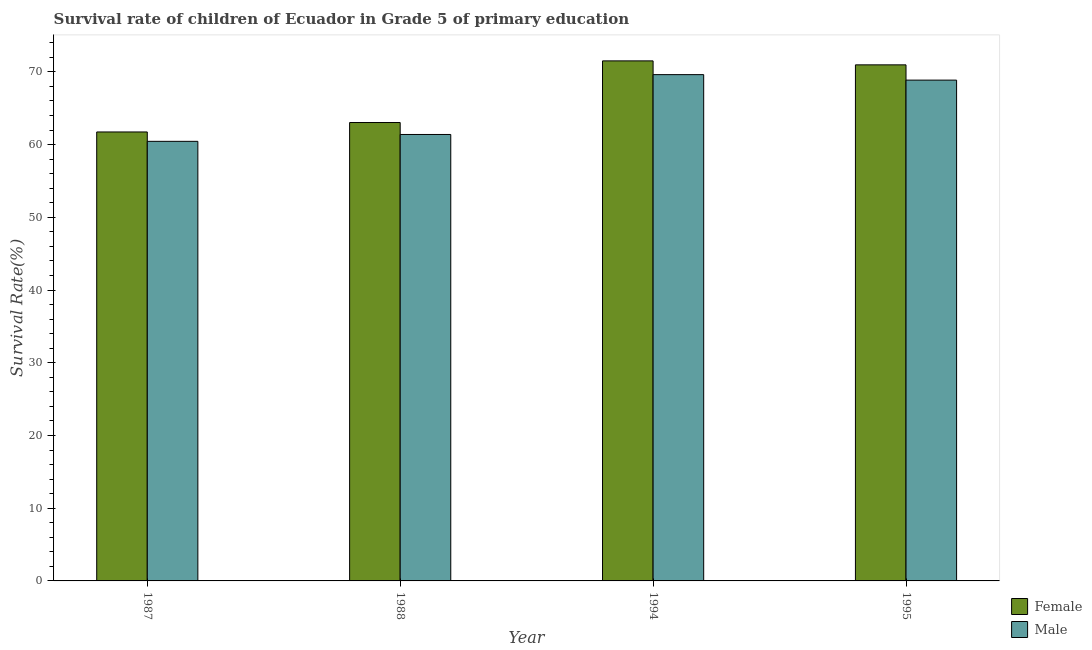How many different coloured bars are there?
Your response must be concise. 2. How many groups of bars are there?
Provide a succinct answer. 4. What is the label of the 1st group of bars from the left?
Your answer should be compact. 1987. In how many cases, is the number of bars for a given year not equal to the number of legend labels?
Your response must be concise. 0. What is the survival rate of male students in primary education in 1987?
Provide a short and direct response. 60.45. Across all years, what is the maximum survival rate of male students in primary education?
Offer a terse response. 69.62. Across all years, what is the minimum survival rate of male students in primary education?
Your response must be concise. 60.45. In which year was the survival rate of male students in primary education maximum?
Your answer should be very brief. 1994. What is the total survival rate of male students in primary education in the graph?
Offer a terse response. 260.34. What is the difference between the survival rate of male students in primary education in 1988 and that in 1994?
Your answer should be very brief. -8.23. What is the difference between the survival rate of male students in primary education in 1988 and the survival rate of female students in primary education in 1987?
Provide a short and direct response. 0.94. What is the average survival rate of male students in primary education per year?
Offer a terse response. 65.09. In the year 1995, what is the difference between the survival rate of male students in primary education and survival rate of female students in primary education?
Offer a very short reply. 0. In how many years, is the survival rate of female students in primary education greater than 60 %?
Offer a very short reply. 4. What is the ratio of the survival rate of male students in primary education in 1987 to that in 1988?
Offer a very short reply. 0.98. Is the difference between the survival rate of female students in primary education in 1988 and 1994 greater than the difference between the survival rate of male students in primary education in 1988 and 1994?
Your answer should be very brief. No. What is the difference between the highest and the second highest survival rate of male students in primary education?
Provide a succinct answer. 0.75. What is the difference between the highest and the lowest survival rate of female students in primary education?
Your answer should be compact. 9.78. Is the sum of the survival rate of male students in primary education in 1988 and 1995 greater than the maximum survival rate of female students in primary education across all years?
Ensure brevity in your answer.  Yes. What does the 2nd bar from the left in 1988 represents?
Keep it short and to the point. Male. What does the 2nd bar from the right in 1994 represents?
Ensure brevity in your answer.  Female. How many bars are there?
Provide a short and direct response. 8. What is the difference between two consecutive major ticks on the Y-axis?
Offer a very short reply. 10. Does the graph contain grids?
Provide a short and direct response. No. Where does the legend appear in the graph?
Provide a succinct answer. Bottom right. What is the title of the graph?
Offer a terse response. Survival rate of children of Ecuador in Grade 5 of primary education. Does "Birth rate" appear as one of the legend labels in the graph?
Offer a very short reply. No. What is the label or title of the Y-axis?
Your response must be concise. Survival Rate(%). What is the Survival Rate(%) of Female in 1987?
Provide a succinct answer. 61.74. What is the Survival Rate(%) of Male in 1987?
Your answer should be very brief. 60.45. What is the Survival Rate(%) of Female in 1988?
Ensure brevity in your answer.  63.04. What is the Survival Rate(%) of Male in 1988?
Keep it short and to the point. 61.39. What is the Survival Rate(%) in Female in 1994?
Keep it short and to the point. 71.52. What is the Survival Rate(%) in Male in 1994?
Offer a terse response. 69.62. What is the Survival Rate(%) of Female in 1995?
Give a very brief answer. 70.97. What is the Survival Rate(%) in Male in 1995?
Your answer should be compact. 68.87. Across all years, what is the maximum Survival Rate(%) in Female?
Offer a terse response. 71.52. Across all years, what is the maximum Survival Rate(%) of Male?
Your response must be concise. 69.62. Across all years, what is the minimum Survival Rate(%) of Female?
Keep it short and to the point. 61.74. Across all years, what is the minimum Survival Rate(%) in Male?
Provide a succinct answer. 60.45. What is the total Survival Rate(%) in Female in the graph?
Your answer should be compact. 267.26. What is the total Survival Rate(%) in Male in the graph?
Provide a succinct answer. 260.34. What is the difference between the Survival Rate(%) of Female in 1987 and that in 1988?
Your response must be concise. -1.3. What is the difference between the Survival Rate(%) in Male in 1987 and that in 1988?
Ensure brevity in your answer.  -0.94. What is the difference between the Survival Rate(%) in Female in 1987 and that in 1994?
Your response must be concise. -9.78. What is the difference between the Survival Rate(%) of Male in 1987 and that in 1994?
Make the answer very short. -9.17. What is the difference between the Survival Rate(%) of Female in 1987 and that in 1995?
Give a very brief answer. -9.23. What is the difference between the Survival Rate(%) in Male in 1987 and that in 1995?
Ensure brevity in your answer.  -8.42. What is the difference between the Survival Rate(%) of Female in 1988 and that in 1994?
Make the answer very short. -8.48. What is the difference between the Survival Rate(%) of Male in 1988 and that in 1994?
Your response must be concise. -8.23. What is the difference between the Survival Rate(%) in Female in 1988 and that in 1995?
Provide a succinct answer. -7.93. What is the difference between the Survival Rate(%) of Male in 1988 and that in 1995?
Provide a short and direct response. -7.48. What is the difference between the Survival Rate(%) of Female in 1994 and that in 1995?
Your answer should be compact. 0.55. What is the difference between the Survival Rate(%) of Male in 1994 and that in 1995?
Provide a succinct answer. 0.75. What is the difference between the Survival Rate(%) of Female in 1987 and the Survival Rate(%) of Male in 1988?
Offer a terse response. 0.34. What is the difference between the Survival Rate(%) of Female in 1987 and the Survival Rate(%) of Male in 1994?
Offer a terse response. -7.88. What is the difference between the Survival Rate(%) of Female in 1987 and the Survival Rate(%) of Male in 1995?
Provide a short and direct response. -7.13. What is the difference between the Survival Rate(%) in Female in 1988 and the Survival Rate(%) in Male in 1994?
Provide a short and direct response. -6.59. What is the difference between the Survival Rate(%) of Female in 1988 and the Survival Rate(%) of Male in 1995?
Provide a short and direct response. -5.83. What is the difference between the Survival Rate(%) of Female in 1994 and the Survival Rate(%) of Male in 1995?
Your response must be concise. 2.65. What is the average Survival Rate(%) in Female per year?
Offer a terse response. 66.82. What is the average Survival Rate(%) of Male per year?
Your answer should be compact. 65.09. In the year 1987, what is the difference between the Survival Rate(%) in Female and Survival Rate(%) in Male?
Keep it short and to the point. 1.29. In the year 1988, what is the difference between the Survival Rate(%) of Female and Survival Rate(%) of Male?
Keep it short and to the point. 1.64. In the year 1994, what is the difference between the Survival Rate(%) in Female and Survival Rate(%) in Male?
Provide a short and direct response. 1.89. In the year 1995, what is the difference between the Survival Rate(%) in Female and Survival Rate(%) in Male?
Offer a terse response. 2.1. What is the ratio of the Survival Rate(%) of Female in 1987 to that in 1988?
Ensure brevity in your answer.  0.98. What is the ratio of the Survival Rate(%) of Male in 1987 to that in 1988?
Offer a terse response. 0.98. What is the ratio of the Survival Rate(%) of Female in 1987 to that in 1994?
Offer a terse response. 0.86. What is the ratio of the Survival Rate(%) in Male in 1987 to that in 1994?
Offer a terse response. 0.87. What is the ratio of the Survival Rate(%) of Female in 1987 to that in 1995?
Make the answer very short. 0.87. What is the ratio of the Survival Rate(%) in Male in 1987 to that in 1995?
Offer a very short reply. 0.88. What is the ratio of the Survival Rate(%) in Female in 1988 to that in 1994?
Your answer should be compact. 0.88. What is the ratio of the Survival Rate(%) in Male in 1988 to that in 1994?
Your response must be concise. 0.88. What is the ratio of the Survival Rate(%) in Female in 1988 to that in 1995?
Keep it short and to the point. 0.89. What is the ratio of the Survival Rate(%) in Male in 1988 to that in 1995?
Make the answer very short. 0.89. What is the ratio of the Survival Rate(%) of Female in 1994 to that in 1995?
Provide a succinct answer. 1.01. What is the ratio of the Survival Rate(%) in Male in 1994 to that in 1995?
Give a very brief answer. 1.01. What is the difference between the highest and the second highest Survival Rate(%) of Female?
Your response must be concise. 0.55. What is the difference between the highest and the second highest Survival Rate(%) in Male?
Keep it short and to the point. 0.75. What is the difference between the highest and the lowest Survival Rate(%) of Female?
Your response must be concise. 9.78. What is the difference between the highest and the lowest Survival Rate(%) of Male?
Make the answer very short. 9.17. 